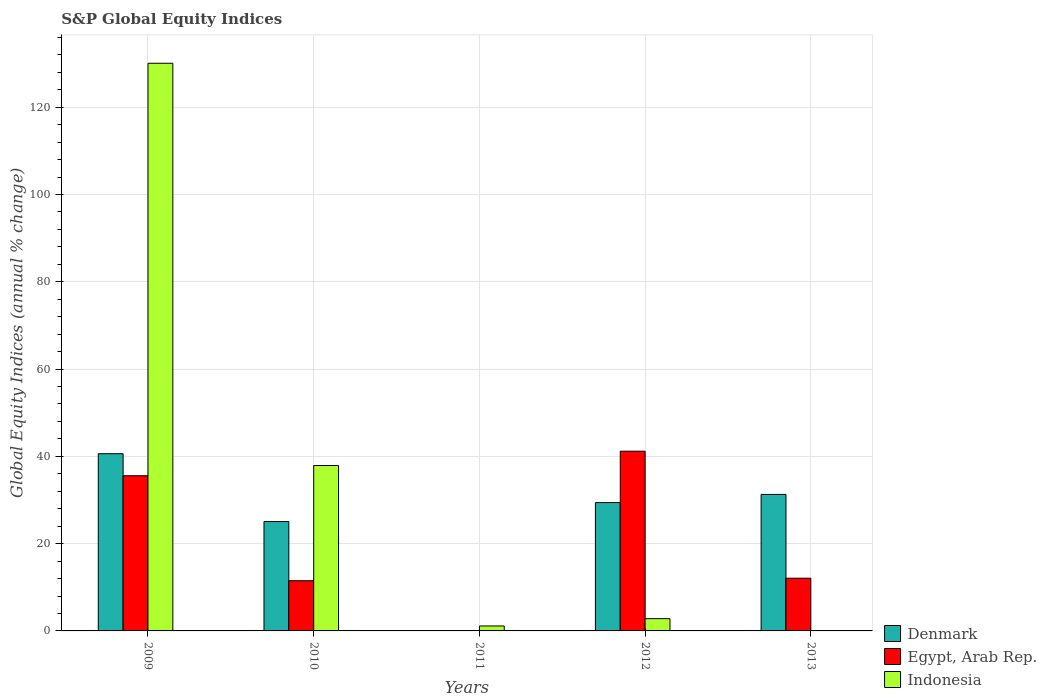How many different coloured bars are there?
Give a very brief answer. 3. Are the number of bars per tick equal to the number of legend labels?
Your response must be concise. No. What is the label of the 3rd group of bars from the left?
Offer a terse response. 2011. In how many cases, is the number of bars for a given year not equal to the number of legend labels?
Offer a very short reply. 2. What is the global equity indices in Denmark in 2009?
Keep it short and to the point. 40.6. Across all years, what is the maximum global equity indices in Egypt, Arab Rep.?
Give a very brief answer. 41.18. Across all years, what is the minimum global equity indices in Denmark?
Your answer should be compact. 0. In which year was the global equity indices in Denmark maximum?
Offer a very short reply. 2009. What is the total global equity indices in Egypt, Arab Rep. in the graph?
Ensure brevity in your answer.  100.31. What is the difference between the global equity indices in Egypt, Arab Rep. in 2010 and that in 2012?
Give a very brief answer. -29.68. What is the difference between the global equity indices in Indonesia in 2011 and the global equity indices in Egypt, Arab Rep. in 2013?
Provide a short and direct response. -10.94. What is the average global equity indices in Indonesia per year?
Give a very brief answer. 34.38. In the year 2012, what is the difference between the global equity indices in Indonesia and global equity indices in Denmark?
Your answer should be compact. -26.59. What is the ratio of the global equity indices in Egypt, Arab Rep. in 2010 to that in 2013?
Offer a very short reply. 0.95. What is the difference between the highest and the second highest global equity indices in Egypt, Arab Rep.?
Give a very brief answer. 5.62. What is the difference between the highest and the lowest global equity indices in Indonesia?
Give a very brief answer. 130.07. How many bars are there?
Provide a succinct answer. 12. How many years are there in the graph?
Your answer should be very brief. 5. Are the values on the major ticks of Y-axis written in scientific E-notation?
Your answer should be very brief. No. Does the graph contain any zero values?
Ensure brevity in your answer.  Yes. How many legend labels are there?
Keep it short and to the point. 3. How are the legend labels stacked?
Provide a short and direct response. Vertical. What is the title of the graph?
Ensure brevity in your answer.  S&P Global Equity Indices. Does "Korea (Republic)" appear as one of the legend labels in the graph?
Provide a succinct answer. No. What is the label or title of the Y-axis?
Keep it short and to the point. Global Equity Indices (annual % change). What is the Global Equity Indices (annual % change) of Denmark in 2009?
Provide a short and direct response. 40.6. What is the Global Equity Indices (annual % change) of Egypt, Arab Rep. in 2009?
Keep it short and to the point. 35.55. What is the Global Equity Indices (annual % change) in Indonesia in 2009?
Your response must be concise. 130.07. What is the Global Equity Indices (annual % change) in Denmark in 2010?
Offer a terse response. 25.06. What is the Global Equity Indices (annual % change) in Egypt, Arab Rep. in 2010?
Your answer should be compact. 11.5. What is the Global Equity Indices (annual % change) in Indonesia in 2010?
Provide a succinct answer. 37.89. What is the Global Equity Indices (annual % change) in Denmark in 2011?
Make the answer very short. 0. What is the Global Equity Indices (annual % change) in Egypt, Arab Rep. in 2011?
Ensure brevity in your answer.  0. What is the Global Equity Indices (annual % change) of Indonesia in 2011?
Your response must be concise. 1.14. What is the Global Equity Indices (annual % change) in Denmark in 2012?
Offer a terse response. 29.4. What is the Global Equity Indices (annual % change) in Egypt, Arab Rep. in 2012?
Provide a succinct answer. 41.18. What is the Global Equity Indices (annual % change) in Indonesia in 2012?
Keep it short and to the point. 2.81. What is the Global Equity Indices (annual % change) in Denmark in 2013?
Your answer should be compact. 31.28. What is the Global Equity Indices (annual % change) of Egypt, Arab Rep. in 2013?
Keep it short and to the point. 12.08. What is the Global Equity Indices (annual % change) in Indonesia in 2013?
Make the answer very short. 0. Across all years, what is the maximum Global Equity Indices (annual % change) of Denmark?
Your answer should be compact. 40.6. Across all years, what is the maximum Global Equity Indices (annual % change) in Egypt, Arab Rep.?
Your response must be concise. 41.18. Across all years, what is the maximum Global Equity Indices (annual % change) of Indonesia?
Keep it short and to the point. 130.07. Across all years, what is the minimum Global Equity Indices (annual % change) in Denmark?
Provide a succinct answer. 0. What is the total Global Equity Indices (annual % change) of Denmark in the graph?
Ensure brevity in your answer.  126.35. What is the total Global Equity Indices (annual % change) of Egypt, Arab Rep. in the graph?
Ensure brevity in your answer.  100.31. What is the total Global Equity Indices (annual % change) of Indonesia in the graph?
Provide a succinct answer. 171.91. What is the difference between the Global Equity Indices (annual % change) of Denmark in 2009 and that in 2010?
Your response must be concise. 15.54. What is the difference between the Global Equity Indices (annual % change) in Egypt, Arab Rep. in 2009 and that in 2010?
Provide a succinct answer. 24.05. What is the difference between the Global Equity Indices (annual % change) of Indonesia in 2009 and that in 2010?
Make the answer very short. 92.17. What is the difference between the Global Equity Indices (annual % change) of Indonesia in 2009 and that in 2011?
Offer a very short reply. 128.93. What is the difference between the Global Equity Indices (annual % change) of Denmark in 2009 and that in 2012?
Make the answer very short. 11.2. What is the difference between the Global Equity Indices (annual % change) of Egypt, Arab Rep. in 2009 and that in 2012?
Provide a short and direct response. -5.62. What is the difference between the Global Equity Indices (annual % change) in Indonesia in 2009 and that in 2012?
Make the answer very short. 127.26. What is the difference between the Global Equity Indices (annual % change) of Denmark in 2009 and that in 2013?
Offer a terse response. 9.33. What is the difference between the Global Equity Indices (annual % change) of Egypt, Arab Rep. in 2009 and that in 2013?
Offer a very short reply. 23.48. What is the difference between the Global Equity Indices (annual % change) in Indonesia in 2010 and that in 2011?
Offer a very short reply. 36.76. What is the difference between the Global Equity Indices (annual % change) of Denmark in 2010 and that in 2012?
Provide a succinct answer. -4.34. What is the difference between the Global Equity Indices (annual % change) in Egypt, Arab Rep. in 2010 and that in 2012?
Provide a short and direct response. -29.68. What is the difference between the Global Equity Indices (annual % change) in Indonesia in 2010 and that in 2012?
Keep it short and to the point. 35.08. What is the difference between the Global Equity Indices (annual % change) in Denmark in 2010 and that in 2013?
Provide a short and direct response. -6.21. What is the difference between the Global Equity Indices (annual % change) of Egypt, Arab Rep. in 2010 and that in 2013?
Your answer should be very brief. -0.58. What is the difference between the Global Equity Indices (annual % change) of Indonesia in 2011 and that in 2012?
Make the answer very short. -1.68. What is the difference between the Global Equity Indices (annual % change) in Denmark in 2012 and that in 2013?
Keep it short and to the point. -1.87. What is the difference between the Global Equity Indices (annual % change) in Egypt, Arab Rep. in 2012 and that in 2013?
Provide a succinct answer. 29.1. What is the difference between the Global Equity Indices (annual % change) in Denmark in 2009 and the Global Equity Indices (annual % change) in Egypt, Arab Rep. in 2010?
Make the answer very short. 29.1. What is the difference between the Global Equity Indices (annual % change) of Denmark in 2009 and the Global Equity Indices (annual % change) of Indonesia in 2010?
Your response must be concise. 2.71. What is the difference between the Global Equity Indices (annual % change) of Egypt, Arab Rep. in 2009 and the Global Equity Indices (annual % change) of Indonesia in 2010?
Give a very brief answer. -2.34. What is the difference between the Global Equity Indices (annual % change) in Denmark in 2009 and the Global Equity Indices (annual % change) in Indonesia in 2011?
Keep it short and to the point. 39.47. What is the difference between the Global Equity Indices (annual % change) of Egypt, Arab Rep. in 2009 and the Global Equity Indices (annual % change) of Indonesia in 2011?
Your response must be concise. 34.42. What is the difference between the Global Equity Indices (annual % change) in Denmark in 2009 and the Global Equity Indices (annual % change) in Egypt, Arab Rep. in 2012?
Keep it short and to the point. -0.58. What is the difference between the Global Equity Indices (annual % change) in Denmark in 2009 and the Global Equity Indices (annual % change) in Indonesia in 2012?
Ensure brevity in your answer.  37.79. What is the difference between the Global Equity Indices (annual % change) of Egypt, Arab Rep. in 2009 and the Global Equity Indices (annual % change) of Indonesia in 2012?
Provide a succinct answer. 32.74. What is the difference between the Global Equity Indices (annual % change) of Denmark in 2009 and the Global Equity Indices (annual % change) of Egypt, Arab Rep. in 2013?
Your answer should be compact. 28.52. What is the difference between the Global Equity Indices (annual % change) in Denmark in 2010 and the Global Equity Indices (annual % change) in Indonesia in 2011?
Make the answer very short. 23.93. What is the difference between the Global Equity Indices (annual % change) of Egypt, Arab Rep. in 2010 and the Global Equity Indices (annual % change) of Indonesia in 2011?
Make the answer very short. 10.37. What is the difference between the Global Equity Indices (annual % change) in Denmark in 2010 and the Global Equity Indices (annual % change) in Egypt, Arab Rep. in 2012?
Your response must be concise. -16.11. What is the difference between the Global Equity Indices (annual % change) in Denmark in 2010 and the Global Equity Indices (annual % change) in Indonesia in 2012?
Offer a very short reply. 22.25. What is the difference between the Global Equity Indices (annual % change) in Egypt, Arab Rep. in 2010 and the Global Equity Indices (annual % change) in Indonesia in 2012?
Offer a very short reply. 8.69. What is the difference between the Global Equity Indices (annual % change) in Denmark in 2010 and the Global Equity Indices (annual % change) in Egypt, Arab Rep. in 2013?
Your response must be concise. 12.98. What is the difference between the Global Equity Indices (annual % change) in Denmark in 2012 and the Global Equity Indices (annual % change) in Egypt, Arab Rep. in 2013?
Provide a short and direct response. 17.33. What is the average Global Equity Indices (annual % change) of Denmark per year?
Provide a succinct answer. 25.27. What is the average Global Equity Indices (annual % change) in Egypt, Arab Rep. per year?
Your answer should be compact. 20.06. What is the average Global Equity Indices (annual % change) in Indonesia per year?
Ensure brevity in your answer.  34.38. In the year 2009, what is the difference between the Global Equity Indices (annual % change) of Denmark and Global Equity Indices (annual % change) of Egypt, Arab Rep.?
Make the answer very short. 5.05. In the year 2009, what is the difference between the Global Equity Indices (annual % change) of Denmark and Global Equity Indices (annual % change) of Indonesia?
Your answer should be very brief. -89.46. In the year 2009, what is the difference between the Global Equity Indices (annual % change) of Egypt, Arab Rep. and Global Equity Indices (annual % change) of Indonesia?
Ensure brevity in your answer.  -94.51. In the year 2010, what is the difference between the Global Equity Indices (annual % change) of Denmark and Global Equity Indices (annual % change) of Egypt, Arab Rep.?
Keep it short and to the point. 13.56. In the year 2010, what is the difference between the Global Equity Indices (annual % change) of Denmark and Global Equity Indices (annual % change) of Indonesia?
Offer a terse response. -12.83. In the year 2010, what is the difference between the Global Equity Indices (annual % change) of Egypt, Arab Rep. and Global Equity Indices (annual % change) of Indonesia?
Make the answer very short. -26.39. In the year 2012, what is the difference between the Global Equity Indices (annual % change) of Denmark and Global Equity Indices (annual % change) of Egypt, Arab Rep.?
Ensure brevity in your answer.  -11.77. In the year 2012, what is the difference between the Global Equity Indices (annual % change) of Denmark and Global Equity Indices (annual % change) of Indonesia?
Keep it short and to the point. 26.59. In the year 2012, what is the difference between the Global Equity Indices (annual % change) of Egypt, Arab Rep. and Global Equity Indices (annual % change) of Indonesia?
Provide a succinct answer. 38.37. In the year 2013, what is the difference between the Global Equity Indices (annual % change) of Denmark and Global Equity Indices (annual % change) of Egypt, Arab Rep.?
Offer a very short reply. 19.2. What is the ratio of the Global Equity Indices (annual % change) of Denmark in 2009 to that in 2010?
Provide a succinct answer. 1.62. What is the ratio of the Global Equity Indices (annual % change) of Egypt, Arab Rep. in 2009 to that in 2010?
Offer a very short reply. 3.09. What is the ratio of the Global Equity Indices (annual % change) in Indonesia in 2009 to that in 2010?
Your response must be concise. 3.43. What is the ratio of the Global Equity Indices (annual % change) of Indonesia in 2009 to that in 2011?
Provide a short and direct response. 114.51. What is the ratio of the Global Equity Indices (annual % change) in Denmark in 2009 to that in 2012?
Offer a terse response. 1.38. What is the ratio of the Global Equity Indices (annual % change) of Egypt, Arab Rep. in 2009 to that in 2012?
Your answer should be very brief. 0.86. What is the ratio of the Global Equity Indices (annual % change) of Indonesia in 2009 to that in 2012?
Offer a very short reply. 46.27. What is the ratio of the Global Equity Indices (annual % change) of Denmark in 2009 to that in 2013?
Provide a succinct answer. 1.3. What is the ratio of the Global Equity Indices (annual % change) in Egypt, Arab Rep. in 2009 to that in 2013?
Provide a short and direct response. 2.94. What is the ratio of the Global Equity Indices (annual % change) in Indonesia in 2010 to that in 2011?
Your response must be concise. 33.36. What is the ratio of the Global Equity Indices (annual % change) of Denmark in 2010 to that in 2012?
Give a very brief answer. 0.85. What is the ratio of the Global Equity Indices (annual % change) of Egypt, Arab Rep. in 2010 to that in 2012?
Make the answer very short. 0.28. What is the ratio of the Global Equity Indices (annual % change) in Indonesia in 2010 to that in 2012?
Ensure brevity in your answer.  13.48. What is the ratio of the Global Equity Indices (annual % change) in Denmark in 2010 to that in 2013?
Ensure brevity in your answer.  0.8. What is the ratio of the Global Equity Indices (annual % change) in Egypt, Arab Rep. in 2010 to that in 2013?
Your answer should be compact. 0.95. What is the ratio of the Global Equity Indices (annual % change) in Indonesia in 2011 to that in 2012?
Offer a very short reply. 0.4. What is the ratio of the Global Equity Indices (annual % change) in Denmark in 2012 to that in 2013?
Offer a very short reply. 0.94. What is the ratio of the Global Equity Indices (annual % change) of Egypt, Arab Rep. in 2012 to that in 2013?
Make the answer very short. 3.41. What is the difference between the highest and the second highest Global Equity Indices (annual % change) in Denmark?
Provide a short and direct response. 9.33. What is the difference between the highest and the second highest Global Equity Indices (annual % change) of Egypt, Arab Rep.?
Your answer should be compact. 5.62. What is the difference between the highest and the second highest Global Equity Indices (annual % change) of Indonesia?
Provide a succinct answer. 92.17. What is the difference between the highest and the lowest Global Equity Indices (annual % change) in Denmark?
Make the answer very short. 40.6. What is the difference between the highest and the lowest Global Equity Indices (annual % change) in Egypt, Arab Rep.?
Offer a terse response. 41.18. What is the difference between the highest and the lowest Global Equity Indices (annual % change) in Indonesia?
Ensure brevity in your answer.  130.07. 